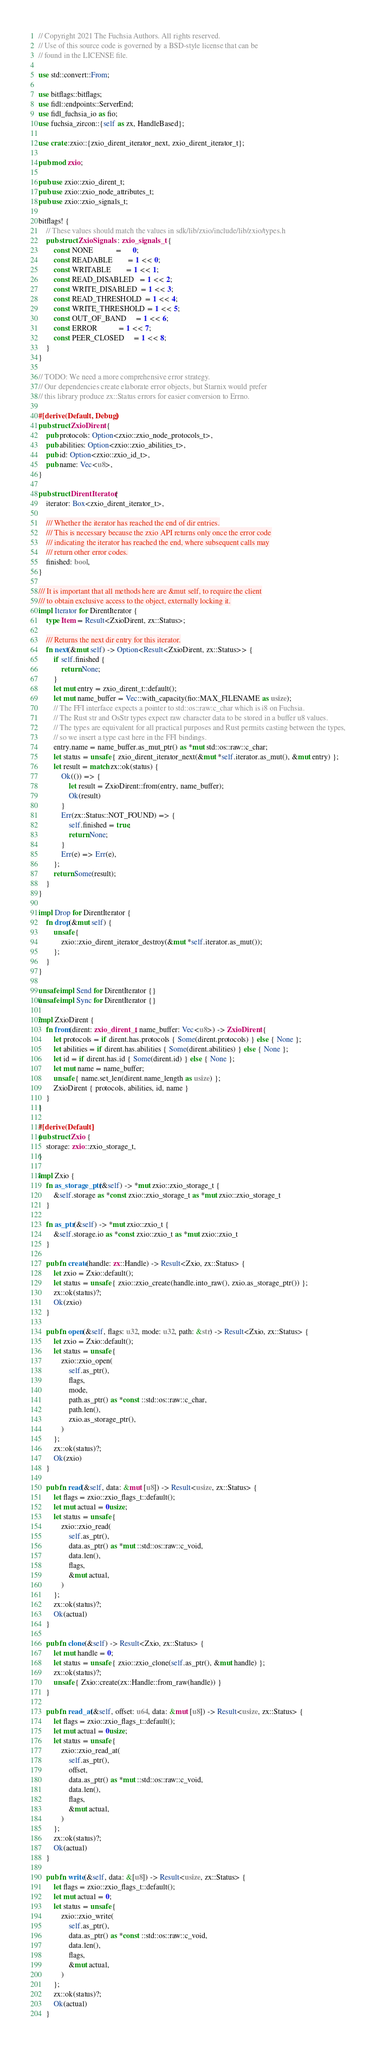Convert code to text. <code><loc_0><loc_0><loc_500><loc_500><_Rust_>// Copyright 2021 The Fuchsia Authors. All rights reserved.
// Use of this source code is governed by a BSD-style license that can be
// found in the LICENSE file.

use std::convert::From;

use bitflags::bitflags;
use fidl::endpoints::ServerEnd;
use fidl_fuchsia_io as fio;
use fuchsia_zircon::{self as zx, HandleBased};

use crate::zxio::{zxio_dirent_iterator_next, zxio_dirent_iterator_t};

pub mod zxio;

pub use zxio::zxio_dirent_t;
pub use zxio::zxio_node_attributes_t;
pub use zxio::zxio_signals_t;

bitflags! {
    // These values should match the values in sdk/lib/zxio/include/lib/zxio/types.h
    pub struct ZxioSignals : zxio_signals_t {
        const NONE            =      0;
        const READABLE        = 1 << 0;
        const WRITABLE        = 1 << 1;
        const READ_DISABLED   = 1 << 2;
        const WRITE_DISABLED  = 1 << 3;
        const READ_THRESHOLD  = 1 << 4;
        const WRITE_THRESHOLD = 1 << 5;
        const OUT_OF_BAND     = 1 << 6;
        const ERROR           = 1 << 7;
        const PEER_CLOSED     = 1 << 8;
    }
}

// TODO: We need a more comprehensive error strategy.
// Our dependencies create elaborate error objects, but Starnix would prefer
// this library produce zx::Status errors for easier conversion to Errno.

#[derive(Default, Debug)]
pub struct ZxioDirent {
    pub protocols: Option<zxio::zxio_node_protocols_t>,
    pub abilities: Option<zxio::zxio_abilities_t>,
    pub id: Option<zxio::zxio_id_t>,
    pub name: Vec<u8>,
}

pub struct DirentIterator {
    iterator: Box<zxio_dirent_iterator_t>,

    /// Whether the iterator has reached the end of dir entries.
    /// This is necessary because the zxio API returns only once the error code
    /// indicating the iterator has reached the end, where subsequent calls may
    /// return other error codes.
    finished: bool,
}

/// It is important that all methods here are &mut self, to require the client
/// to obtain exclusive access to the object, externally locking it.
impl Iterator for DirentIterator {
    type Item = Result<ZxioDirent, zx::Status>;

    /// Returns the next dir entry for this iterator.
    fn next(&mut self) -> Option<Result<ZxioDirent, zx::Status>> {
        if self.finished {
            return None;
        }
        let mut entry = zxio_dirent_t::default();
        let mut name_buffer = Vec::with_capacity(fio::MAX_FILENAME as usize);
        // The FFI interface expects a pointer to std::os::raw:c_char which is i8 on Fuchsia.
        // The Rust str and OsStr types expect raw character data to be stored in a buffer u8 values.
        // The types are equivalent for all practical purposes and Rust permits casting between the types,
        // so we insert a type cast here in the FFI bindings.
        entry.name = name_buffer.as_mut_ptr() as *mut std::os::raw::c_char;
        let status = unsafe { zxio_dirent_iterator_next(&mut *self.iterator.as_mut(), &mut entry) };
        let result = match zx::ok(status) {
            Ok(()) => {
                let result = ZxioDirent::from(entry, name_buffer);
                Ok(result)
            }
            Err(zx::Status::NOT_FOUND) => {
                self.finished = true;
                return None;
            }
            Err(e) => Err(e),
        };
        return Some(result);
    }
}

impl Drop for DirentIterator {
    fn drop(&mut self) {
        unsafe {
            zxio::zxio_dirent_iterator_destroy(&mut *self.iterator.as_mut());
        };
    }
}

unsafe impl Send for DirentIterator {}
unsafe impl Sync for DirentIterator {}

impl ZxioDirent {
    fn from(dirent: zxio_dirent_t, name_buffer: Vec<u8>) -> ZxioDirent {
        let protocols = if dirent.has.protocols { Some(dirent.protocols) } else { None };
        let abilities = if dirent.has.abilities { Some(dirent.abilities) } else { None };
        let id = if dirent.has.id { Some(dirent.id) } else { None };
        let mut name = name_buffer;
        unsafe { name.set_len(dirent.name_length as usize) };
        ZxioDirent { protocols, abilities, id, name }
    }
}

#[derive(Default)]
pub struct Zxio {
    storage: zxio::zxio_storage_t,
}

impl Zxio {
    fn as_storage_ptr(&self) -> *mut zxio::zxio_storage_t {
        &self.storage as *const zxio::zxio_storage_t as *mut zxio::zxio_storage_t
    }

    fn as_ptr(&self) -> *mut zxio::zxio_t {
        &self.storage.io as *const zxio::zxio_t as *mut zxio::zxio_t
    }

    pub fn create(handle: zx::Handle) -> Result<Zxio, zx::Status> {
        let zxio = Zxio::default();
        let status = unsafe { zxio::zxio_create(handle.into_raw(), zxio.as_storage_ptr()) };
        zx::ok(status)?;
        Ok(zxio)
    }

    pub fn open(&self, flags: u32, mode: u32, path: &str) -> Result<Zxio, zx::Status> {
        let zxio = Zxio::default();
        let status = unsafe {
            zxio::zxio_open(
                self.as_ptr(),
                flags,
                mode,
                path.as_ptr() as *const ::std::os::raw::c_char,
                path.len(),
                zxio.as_storage_ptr(),
            )
        };
        zx::ok(status)?;
        Ok(zxio)
    }

    pub fn read(&self, data: &mut [u8]) -> Result<usize, zx::Status> {
        let flags = zxio::zxio_flags_t::default();
        let mut actual = 0usize;
        let status = unsafe {
            zxio::zxio_read(
                self.as_ptr(),
                data.as_ptr() as *mut ::std::os::raw::c_void,
                data.len(),
                flags,
                &mut actual,
            )
        };
        zx::ok(status)?;
        Ok(actual)
    }

    pub fn clone(&self) -> Result<Zxio, zx::Status> {
        let mut handle = 0;
        let status = unsafe { zxio::zxio_clone(self.as_ptr(), &mut handle) };
        zx::ok(status)?;
        unsafe { Zxio::create(zx::Handle::from_raw(handle)) }
    }

    pub fn read_at(&self, offset: u64, data: &mut [u8]) -> Result<usize, zx::Status> {
        let flags = zxio::zxio_flags_t::default();
        let mut actual = 0usize;
        let status = unsafe {
            zxio::zxio_read_at(
                self.as_ptr(),
                offset,
                data.as_ptr() as *mut ::std::os::raw::c_void,
                data.len(),
                flags,
                &mut actual,
            )
        };
        zx::ok(status)?;
        Ok(actual)
    }

    pub fn write(&self, data: &[u8]) -> Result<usize, zx::Status> {
        let flags = zxio::zxio_flags_t::default();
        let mut actual = 0;
        let status = unsafe {
            zxio::zxio_write(
                self.as_ptr(),
                data.as_ptr() as *const ::std::os::raw::c_void,
                data.len(),
                flags,
                &mut actual,
            )
        };
        zx::ok(status)?;
        Ok(actual)
    }
</code> 